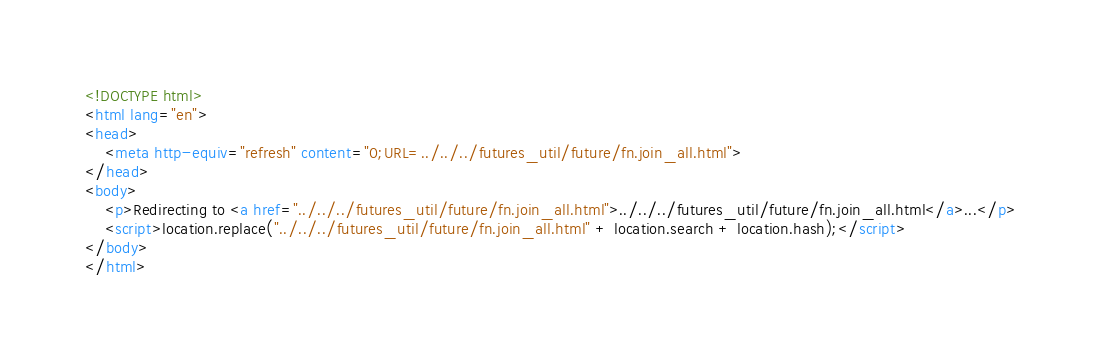Convert code to text. <code><loc_0><loc_0><loc_500><loc_500><_HTML_><!DOCTYPE html>
<html lang="en">
<head>
    <meta http-equiv="refresh" content="0;URL=../../../futures_util/future/fn.join_all.html">
</head>
<body>
    <p>Redirecting to <a href="../../../futures_util/future/fn.join_all.html">../../../futures_util/future/fn.join_all.html</a>...</p>
    <script>location.replace("../../../futures_util/future/fn.join_all.html" + location.search + location.hash);</script>
</body>
</html></code> 